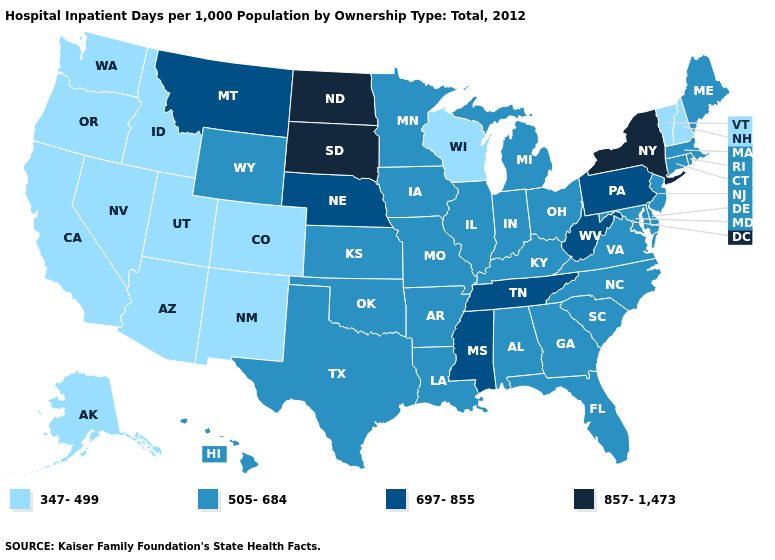Among the states that border Montana , which have the lowest value?
Keep it brief. Idaho. Does Kansas have the highest value in the MidWest?
Give a very brief answer. No. Which states have the lowest value in the MidWest?
Keep it brief. Wisconsin. What is the value of Delaware?
Concise answer only. 505-684. Does Mississippi have the highest value in the South?
Concise answer only. Yes. What is the value of Ohio?
Be succinct. 505-684. Name the states that have a value in the range 347-499?
Write a very short answer. Alaska, Arizona, California, Colorado, Idaho, Nevada, New Hampshire, New Mexico, Oregon, Utah, Vermont, Washington, Wisconsin. Which states have the lowest value in the South?
Keep it brief. Alabama, Arkansas, Delaware, Florida, Georgia, Kentucky, Louisiana, Maryland, North Carolina, Oklahoma, South Carolina, Texas, Virginia. Does the map have missing data?
Be succinct. No. What is the value of Nevada?
Short answer required. 347-499. What is the lowest value in states that border South Dakota?
Keep it brief. 505-684. What is the value of Wyoming?
Concise answer only. 505-684. What is the value of Connecticut?
Quick response, please. 505-684. Which states have the lowest value in the South?
Give a very brief answer. Alabama, Arkansas, Delaware, Florida, Georgia, Kentucky, Louisiana, Maryland, North Carolina, Oklahoma, South Carolina, Texas, Virginia. Which states have the lowest value in the USA?
Keep it brief. Alaska, Arizona, California, Colorado, Idaho, Nevada, New Hampshire, New Mexico, Oregon, Utah, Vermont, Washington, Wisconsin. 